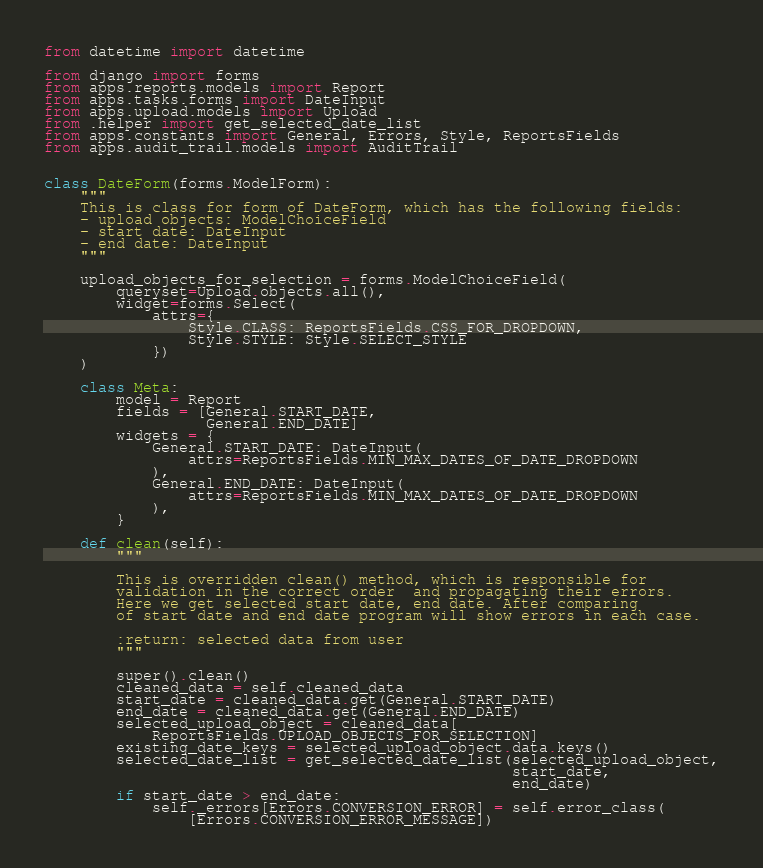Convert code to text. <code><loc_0><loc_0><loc_500><loc_500><_Python_>from datetime import datetime

from django import forms
from apps.reports.models import Report
from apps.tasks.forms import DateInput
from apps.upload.models import Upload
from .helper import get_selected_date_list
from apps.constants import General, Errors, Style, ReportsFields
from apps.audit_trail.models import AuditTrail


class DateForm(forms.ModelForm):
    """
    This is class for form of DateForm, which has the following fields:
    - upload objects: ModelChoiceField
    - start date: DateInput
    - end date: DateInput
    """

    upload_objects_for_selection = forms.ModelChoiceField(
        queryset=Upload.objects.all(),
        widget=forms.Select(
            attrs={
                Style.CLASS: ReportsFields.CSS_FOR_DROPDOWN,
                Style.STYLE: Style.SELECT_STYLE
            })
    )

    class Meta:
        model = Report
        fields = [General.START_DATE,
                  General.END_DATE]
        widgets = {
            General.START_DATE: DateInput(
                attrs=ReportsFields.MIN_MAX_DATES_OF_DATE_DROPDOWN
            ),
            General.END_DATE: DateInput(
                attrs=ReportsFields.MIN_MAX_DATES_OF_DATE_DROPDOWN
            ),
        }

    def clean(self):
        """

        This is overridden clean() method, which is responsible for
        validation in the correct order  and propagating their errors.
        Here we get selected start date, end date. After comparing
        of start date and end date program will show errors in each case.

        :return: selected data from user
        """

        super().clean()
        cleaned_data = self.cleaned_data
        start_date = cleaned_data.get(General.START_DATE)
        end_date = cleaned_data.get(General.END_DATE)
        selected_upload_object = cleaned_data[
            ReportsFields.UPLOAD_OBJECTS_FOR_SELECTION]
        existing_date_keys = selected_upload_object.data.keys()
        selected_date_list = get_selected_date_list(selected_upload_object,
                                                    start_date,
                                                    end_date)
        if start_date > end_date:
            self._errors[Errors.CONVERSION_ERROR] = self.error_class(
                [Errors.CONVERSION_ERROR_MESSAGE])</code> 